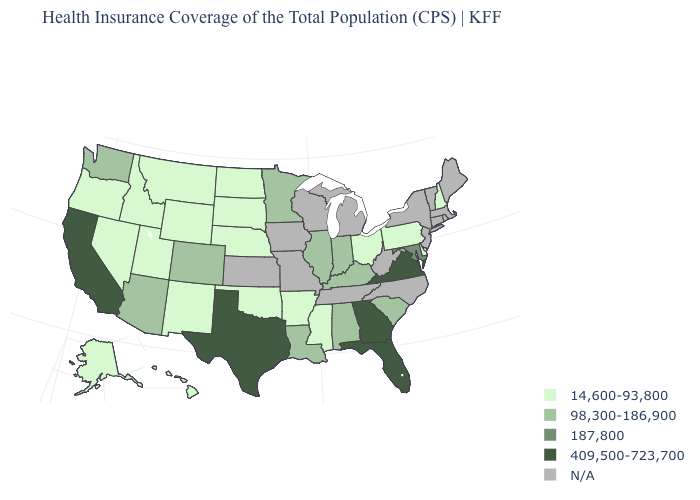What is the value of Alaska?
Write a very short answer. 14,600-93,800. What is the value of New York?
Concise answer only. N/A. Name the states that have a value in the range 98,300-186,900?
Quick response, please. Alabama, Arizona, Colorado, Illinois, Indiana, Kentucky, Louisiana, Minnesota, South Carolina, Washington. Does Arkansas have the lowest value in the South?
Concise answer only. Yes. What is the value of North Carolina?
Give a very brief answer. N/A. Does Arkansas have the lowest value in the USA?
Keep it brief. Yes. What is the highest value in states that border North Carolina?
Short answer required. 409,500-723,700. Among the states that border Tennessee , which have the highest value?
Give a very brief answer. Georgia, Virginia. What is the lowest value in the South?
Keep it brief. 14,600-93,800. Which states have the lowest value in the Northeast?
Quick response, please. New Hampshire, Pennsylvania. Name the states that have a value in the range 14,600-93,800?
Write a very short answer. Alaska, Arkansas, Delaware, Hawaii, Idaho, Mississippi, Montana, Nebraska, Nevada, New Hampshire, New Mexico, North Dakota, Ohio, Oklahoma, Oregon, Pennsylvania, South Dakota, Utah, Wyoming. Name the states that have a value in the range 14,600-93,800?
Write a very short answer. Alaska, Arkansas, Delaware, Hawaii, Idaho, Mississippi, Montana, Nebraska, Nevada, New Hampshire, New Mexico, North Dakota, Ohio, Oklahoma, Oregon, Pennsylvania, South Dakota, Utah, Wyoming. Name the states that have a value in the range 409,500-723,700?
Answer briefly. California, Florida, Georgia, Texas, Virginia. Name the states that have a value in the range N/A?
Quick response, please. Connecticut, Iowa, Kansas, Maine, Massachusetts, Michigan, Missouri, New Jersey, New York, North Carolina, Rhode Island, Tennessee, Vermont, West Virginia, Wisconsin. 